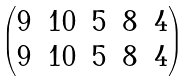Convert formula to latex. <formula><loc_0><loc_0><loc_500><loc_500>\begin{pmatrix} 9 & 1 0 & 5 & 8 & 4 \\ 9 & 1 0 & 5 & 8 & 4 \end{pmatrix}</formula> 